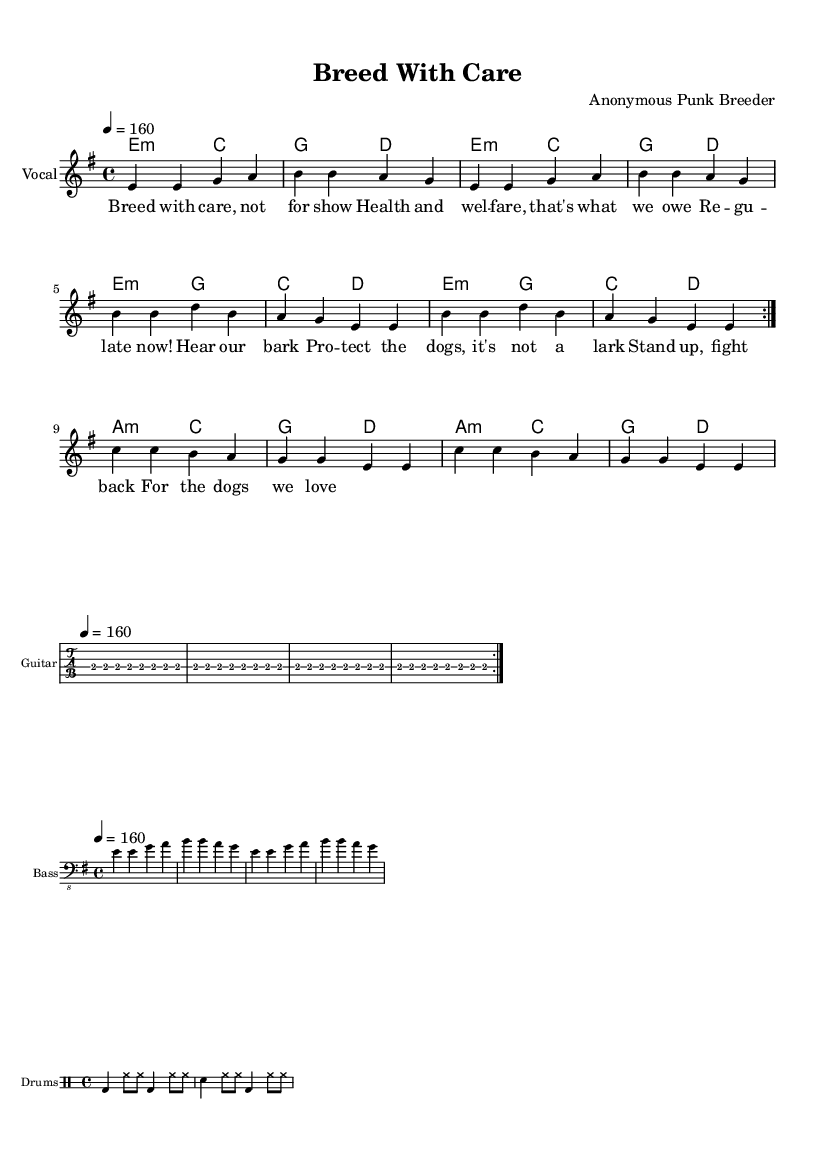What is the key signature of this music? The key signature is E minor, indicated by one sharp (F#).
Answer: E minor What is the time signature of this piece? The time signature is 4/4, as indicated at the beginning of the score.
Answer: 4/4 What is the tempo marking for this piece? The tempo is marked at quarter note = 160 beats per minute, as shown in the tempo marking.
Answer: 160 How many verses are repeated in the melody? The melody repeats for two verses, as indicated by the "repeat volta 2" instruction.
Answer: 2 What is the primary theme of the lyrics? The theme revolves around better animal welfare and dog breeding regulations, as reflected in phrases like "Breed with care" and "Regulate now!"
Answer: Animal welfare What type of instrument plays the melody in this score? The melody is played by a vocal instrument, as indicated in the staff label.
Answer: Vocal What rhythmic pattern is used for the drums in this piece? The drums use a consistent pattern of bass and hi-hat alternating with snare, detailed in the drummode section.
Answer: Bass and hi-hat 